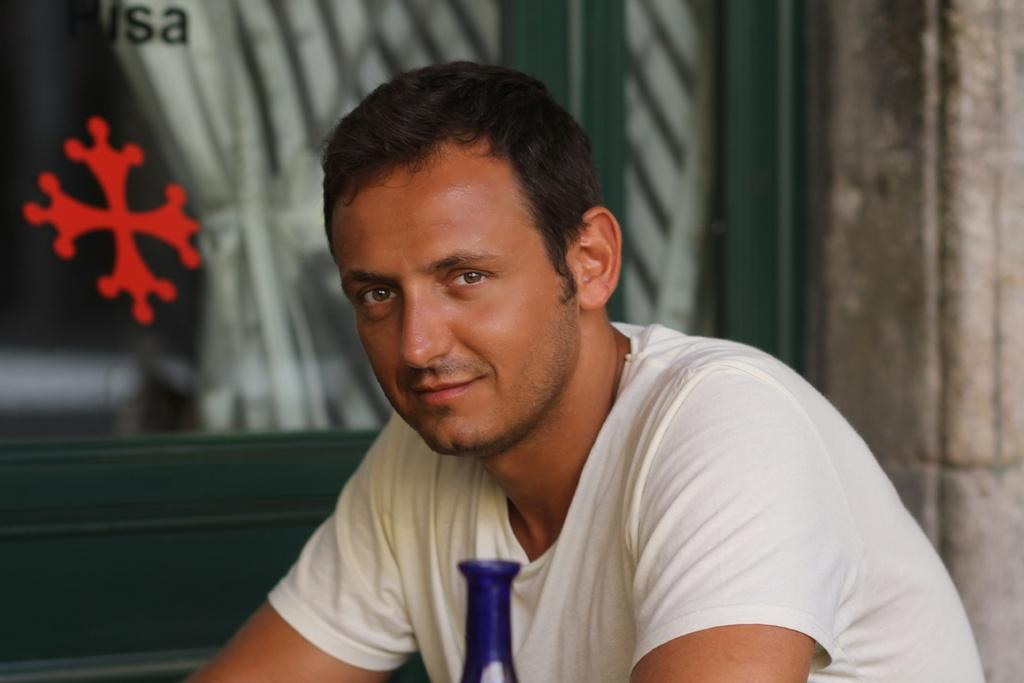Who or what is present in the image? There is a person in the image. What is the person doing in the image? The person is staring. What can be seen in the background of the image? There is a wooden door with a glass on it in the background. What type of juice can be smelled in the image? There is no juice present in the image, so it cannot be smelled. 